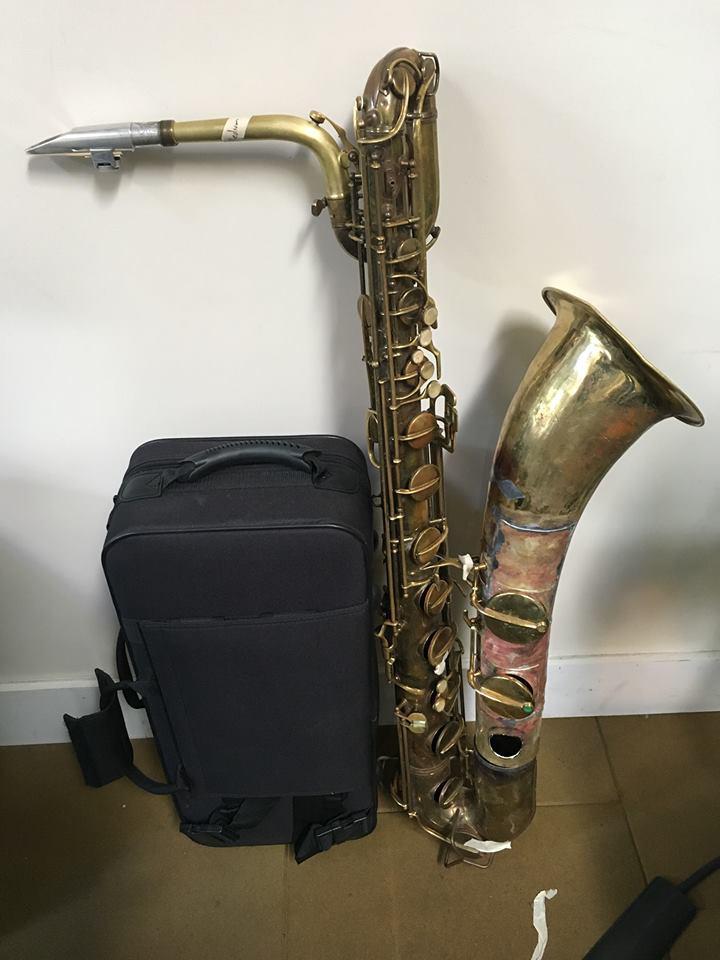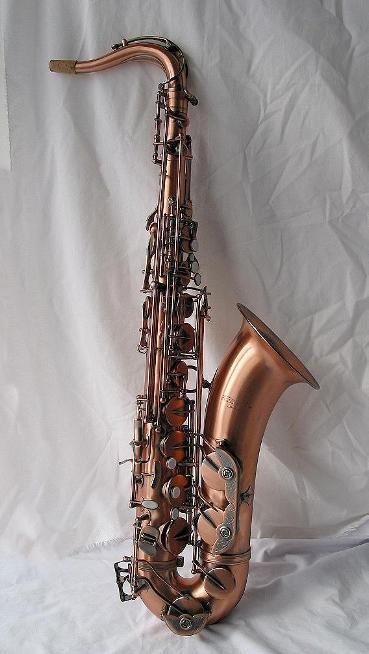The first image is the image on the left, the second image is the image on the right. For the images displayed, is the sentence "The reed end of two saxophones angles upward." factually correct? Answer yes or no. No. The first image is the image on the left, the second image is the image on the right. Analyze the images presented: Is the assertion "An image shows an instrument with a very dark finish and brass works." valid? Answer yes or no. No. 